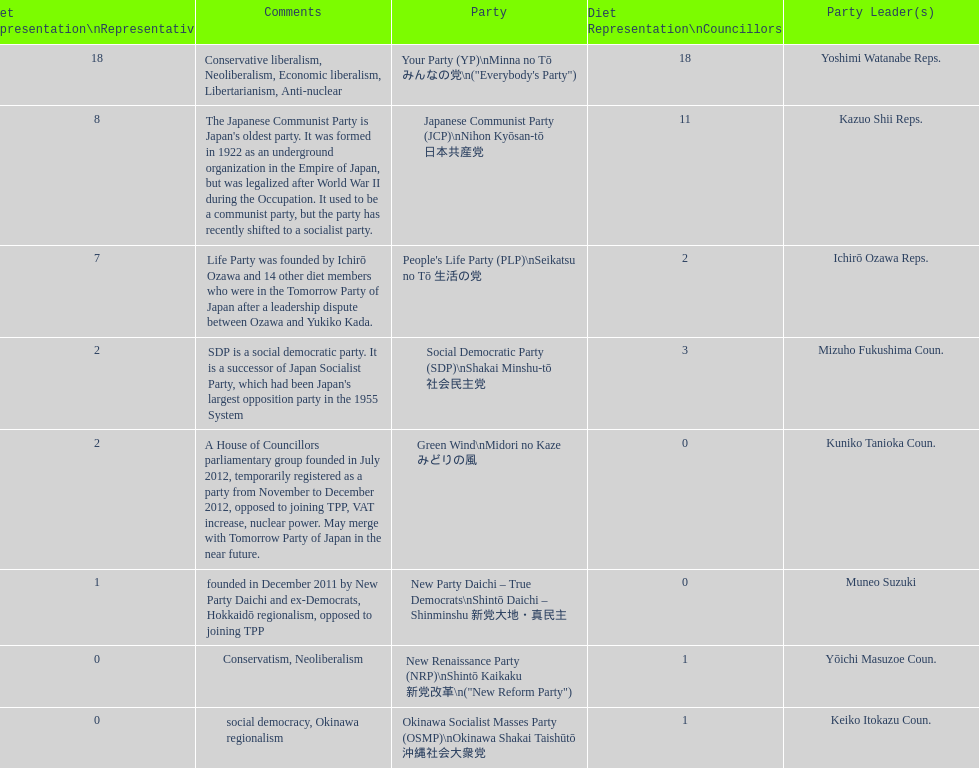How many of these parties currently have no councillors? 2. 